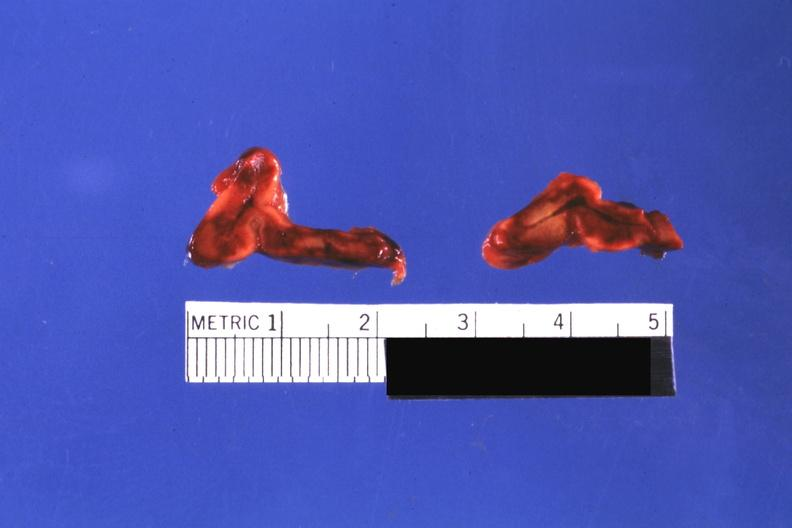what do not know history?
Answer the question using a single word or phrase. Focal hemorrhagic infarction well shown 